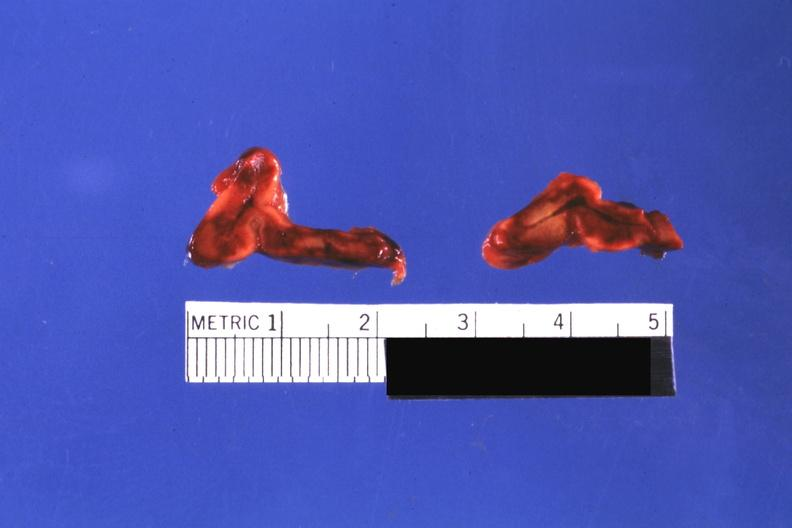what do not know history?
Answer the question using a single word or phrase. Focal hemorrhagic infarction well shown 